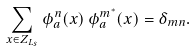Convert formula to latex. <formula><loc_0><loc_0><loc_500><loc_500>\sum _ { x \in Z _ { L _ { s } } } \phi ^ { n } _ { a } ( x ) \, \phi ^ { m ^ { * } } _ { a } ( x ) = \delta _ { m n } .</formula> 